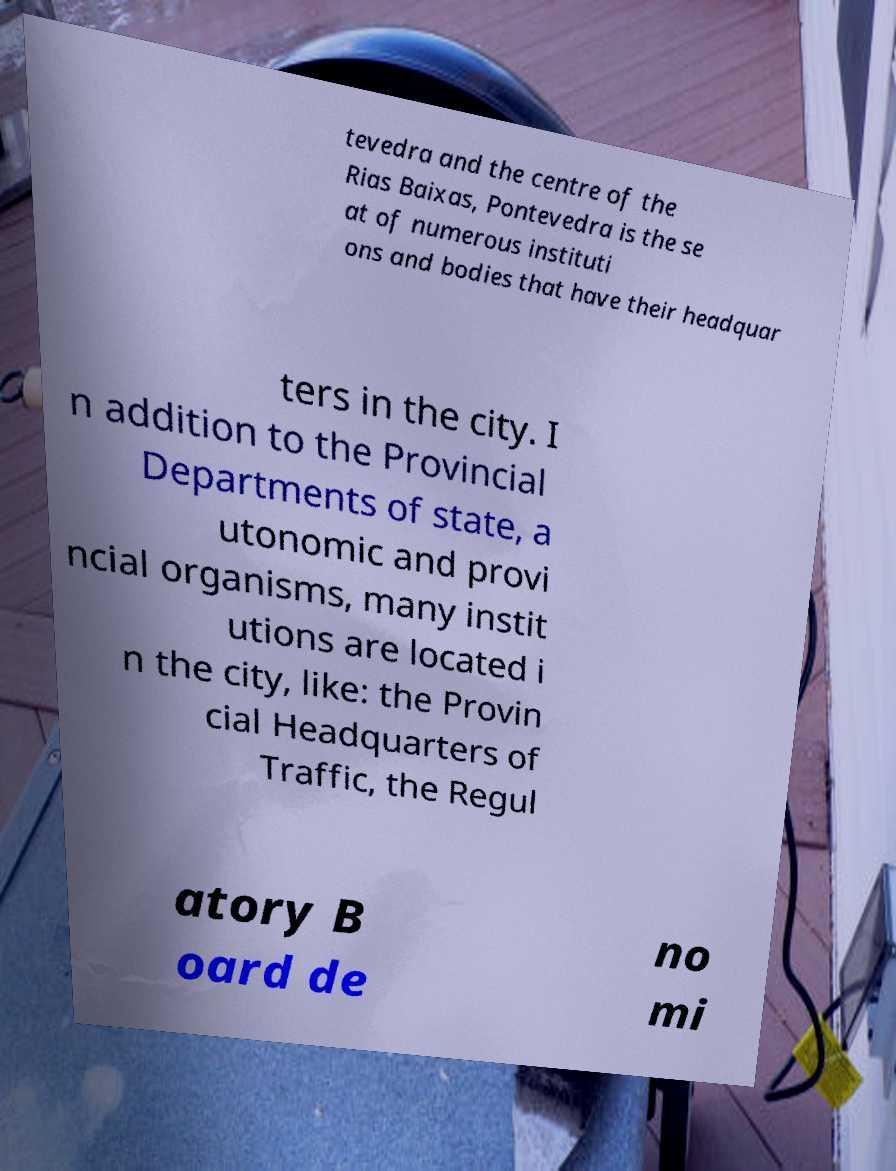Can you read and provide the text displayed in the image?This photo seems to have some interesting text. Can you extract and type it out for me? tevedra and the centre of the Rias Baixas, Pontevedra is the se at of numerous instituti ons and bodies that have their headquar ters in the city. I n addition to the Provincial Departments of state, a utonomic and provi ncial organisms, many instit utions are located i n the city, like: the Provin cial Headquarters of Traffic, the Regul atory B oard de no mi 